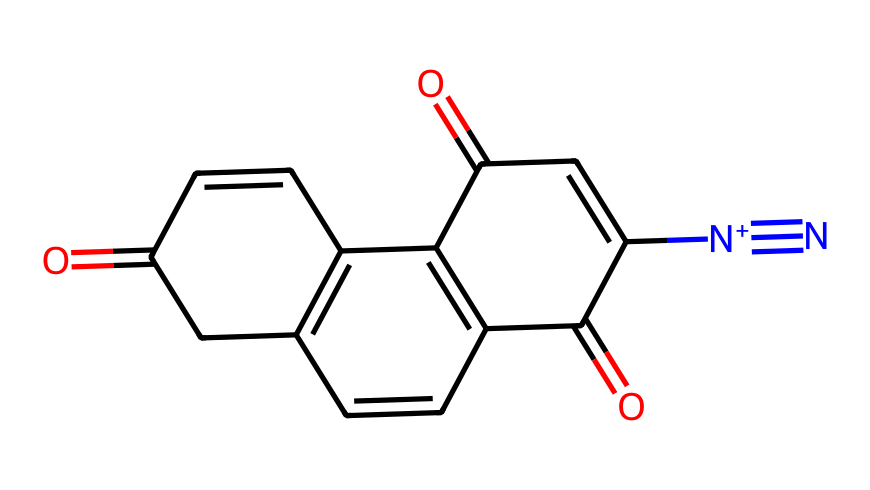What is the molecular formula of DNQ? The molecular formula can be derived by counting the atoms represented in the SMILES. By identifying Carbon (C), Hydrogen (H), Oxygen (O), and Nitrogen (N) atoms, we find a total of 15 Carbons, 11 Hydrogens, 4 Oxygens, and 2 Nitrogens, leading to the molecular formula C15H11N2O4.
Answer: C15H11N2O4 How many rings are present in the molecular structure of DNQ? To determine the number of rings, we can visually inspect the structure from the SMILES. The presence of C=C connections in a closed loop reveals that there are three interconnected rings in the structure.
Answer: 3 What type of functional groups does DNQ possess? By examining the SMILES representation, we can identify that the molecule contains carbonyl (C=O) and nitro (N+) functional groups. The presence of these groups can be confirmed by their characteristic positioning and bonding.
Answer: carbonyl, nitro How does the presence of the nitro group affect the reactivity of DNQ? The nitro group attached to the carbon structure increases the electron deficiency of the molecule, making it more susceptible to nucleophilic attack. This contributes to the electrophilic character of the compound, enhancing its reactivity, especially during photochemical processes.
Answer: increases reactivity What role does DNQ play in photoresists? DNQ serves as a photosensitive compound that undergoes a chemical change upon exposure to light, allowing it to facilitate pattern formation during the photolithography process. This is indicative of its application in creating microelectronic devices.
Answer: photosensitive agent What is the significance of the diazo group in DNQ? The diazo group (N+=N) contributes to the photosensitivity of DNQ, enabling it to undergo photodecomposition. This change is pivotal during exposure in photolithography, allowing selective removal of the exposed areas to create patterns.
Answer: photodecomposition What is the effect of UV light on DNQ? UV light initiates the photochemical reaction in DNQ leading to the loss of the active diazo structure and forming new compounds that modify the solubility of the photoresist. This alteration is essential for defining patterns in semiconductor manufacturing processes.
Answer: alters solubility 